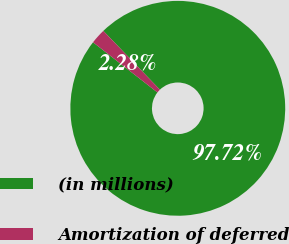Convert chart. <chart><loc_0><loc_0><loc_500><loc_500><pie_chart><fcel>(in millions)<fcel>Amortization of deferred<nl><fcel>97.72%<fcel>2.28%<nl></chart> 